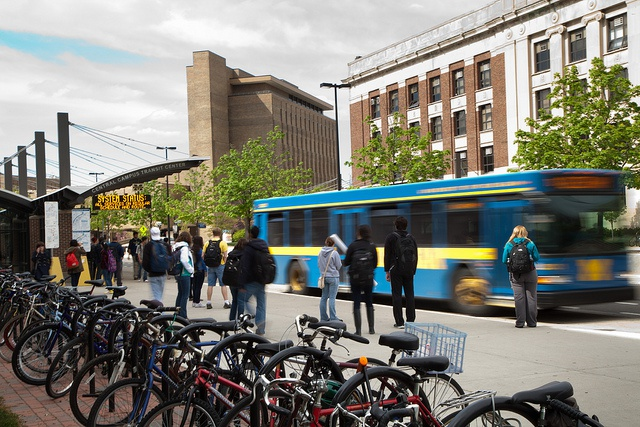Describe the objects in this image and their specific colors. I can see bus in lightgray, black, darkblue, blue, and gray tones, bicycle in lightgray, black, gray, darkgray, and darkgreen tones, bicycle in lightgray, black, gray, and maroon tones, bicycle in lightgray, black, gray, and navy tones, and bicycle in lightgray, black, gray, maroon, and darkgray tones in this image. 